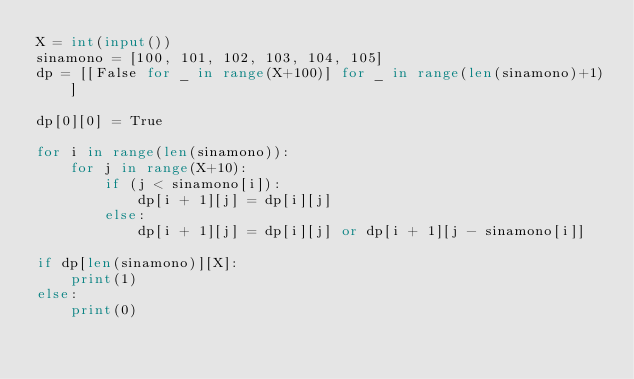<code> <loc_0><loc_0><loc_500><loc_500><_Python_>X = int(input())
sinamono = [100, 101, 102, 103, 104, 105]
dp = [[False for _ in range(X+100)] for _ in range(len(sinamono)+1)]

dp[0][0] = True

for i in range(len(sinamono)):
    for j in range(X+10):
        if (j < sinamono[i]):
            dp[i + 1][j] = dp[i][j]
        else:
            dp[i + 1][j] = dp[i][j] or dp[i + 1][j - sinamono[i]]

if dp[len(sinamono)][X]:
    print(1)
else:
    print(0)</code> 